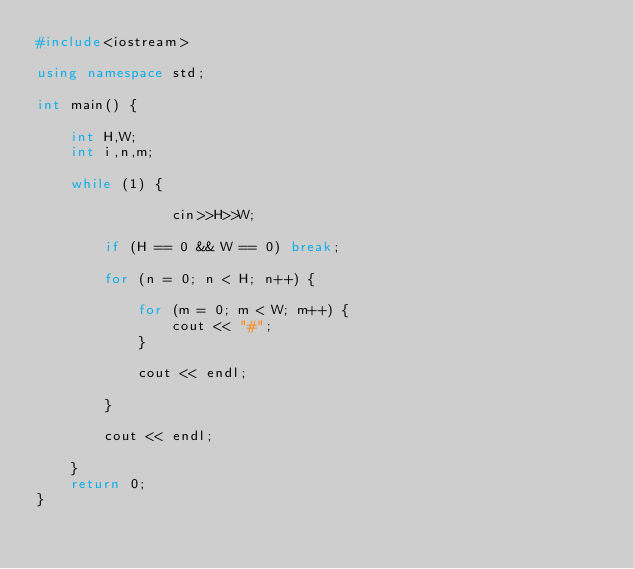Convert code to text. <code><loc_0><loc_0><loc_500><loc_500><_C++_>#include<iostream>

using namespace std;

int main() {

	int H,W;
	int i,n,m;

	while (1) {

                cin>>H>>W;

		if (H == 0 && W == 0) break;

		for (n = 0; n < H; n++) {

			for (m = 0; m < W; m++) {
				cout << "#";
			}

			cout << endl;

		}

		cout << endl;

	}
	return 0;
}</code> 